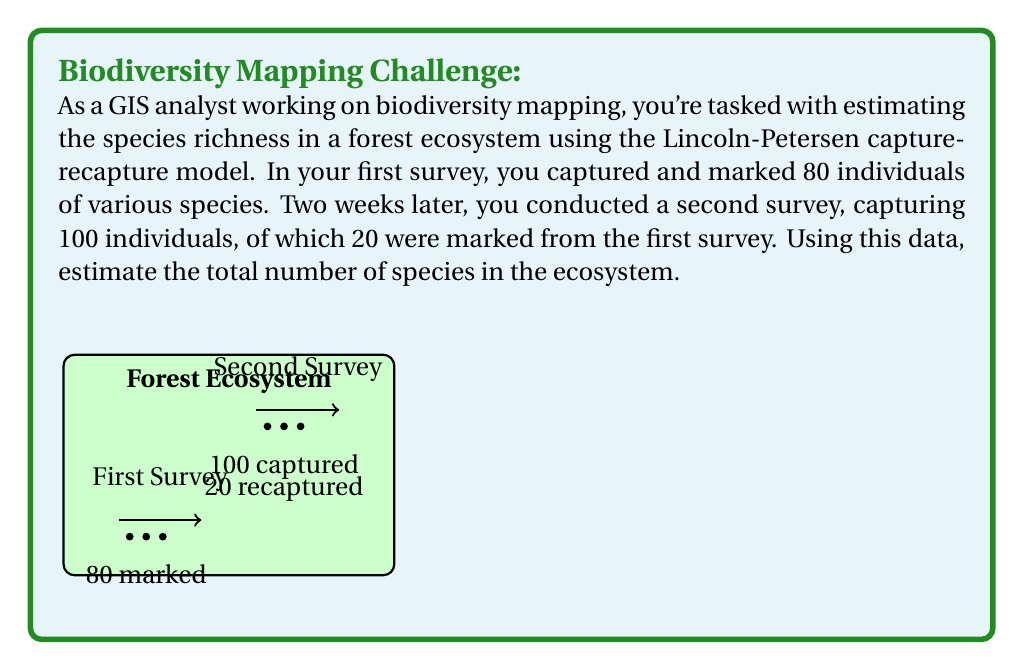Could you help me with this problem? To estimate the total number of species in the ecosystem using the Lincoln-Petersen capture-recapture model, we'll follow these steps:

1) The Lincoln-Petersen model is given by the equation:

   $$N = \frac{M \times C}{R}$$

   Where:
   $N$ = estimated total population size
   $M$ = number of individuals marked in the first sample
   $C$ = total number of individuals captured in the second sample
   $R$ = number of marked individuals recaptured in the second sample

2) From the given data:
   $M = 80$ (marked in first survey)
   $C = 100$ (captured in second survey)
   $R = 20$ (recaptured marked individuals)

3) Plugging these values into the equation:

   $$N = \frac{80 \times 100}{20}$$

4) Simplify:
   $$N = \frac{8000}{20} = 400$$

5) Therefore, the estimated total number of species in the ecosystem is 400.

Note: This model assumes a closed population (no births, deaths, immigration, or emigration between surveys) and that all individuals have an equal chance of being captured. In real-world GIS applications, you might need to consider more complex models to account for various factors affecting species distribution and capture probability.
Answer: 400 species 